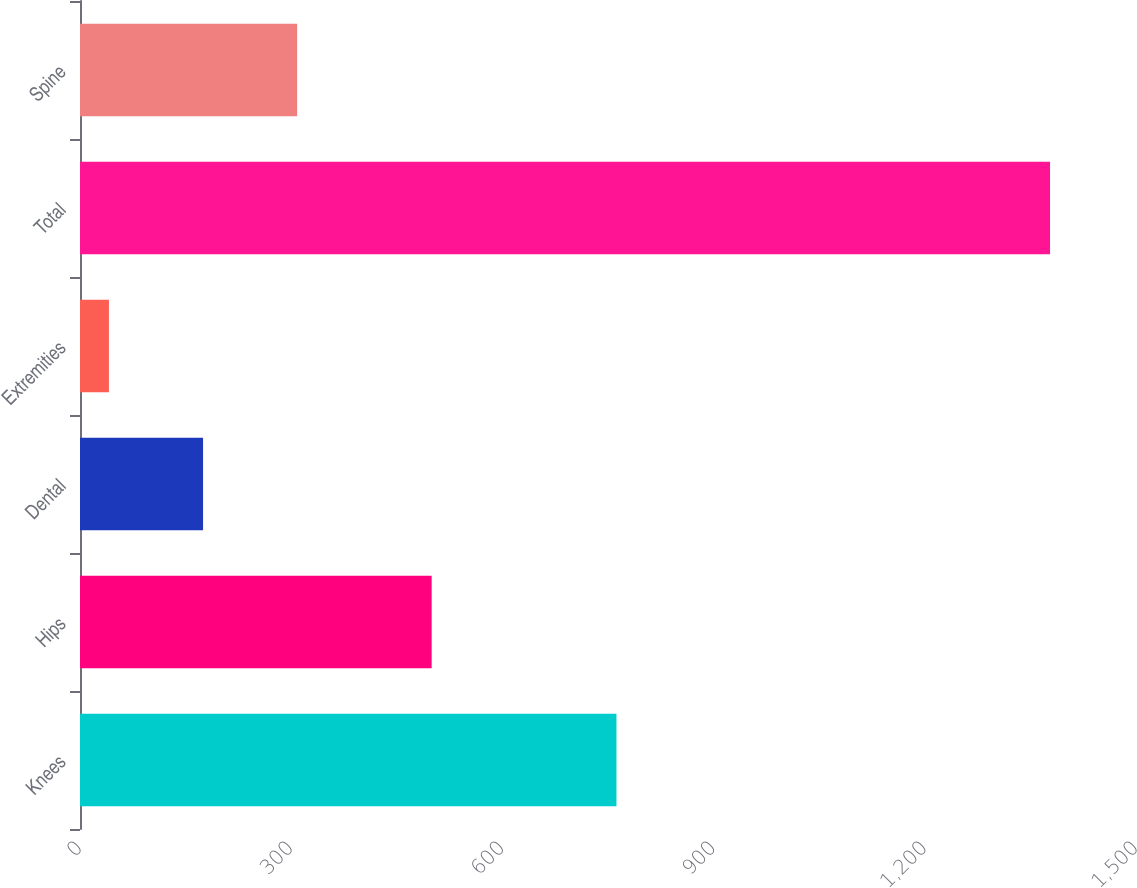Convert chart. <chart><loc_0><loc_0><loc_500><loc_500><bar_chart><fcel>Knees<fcel>Hips<fcel>Dental<fcel>Extremities<fcel>Total<fcel>Spine<nl><fcel>762<fcel>499.5<fcel>174.78<fcel>41.1<fcel>1377.9<fcel>308.46<nl></chart> 